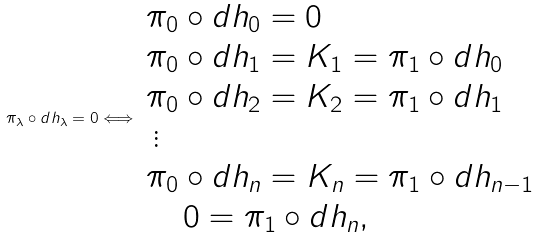Convert formula to latex. <formula><loc_0><loc_0><loc_500><loc_500>\pi _ { \lambda } \circ d h _ { \lambda } = 0 \Longleftrightarrow \begin{array} { l } \pi _ { 0 } \circ d h _ { 0 } = 0 \\ \pi _ { 0 } \circ d h _ { 1 } = K _ { 1 } = \pi _ { 1 } \circ d h _ { 0 } \\ \pi _ { 0 } \circ d h _ { 2 } = K _ { 2 } = \pi _ { 1 } \circ d h _ { 1 } \\ \, \vdots \\ \pi _ { 0 } \circ d h _ { n } = K _ { n } = \pi _ { 1 } \circ d h _ { n - 1 } \\ \quad \, 0 = \pi _ { 1 } \circ d h _ { n } , \, \end{array}</formula> 